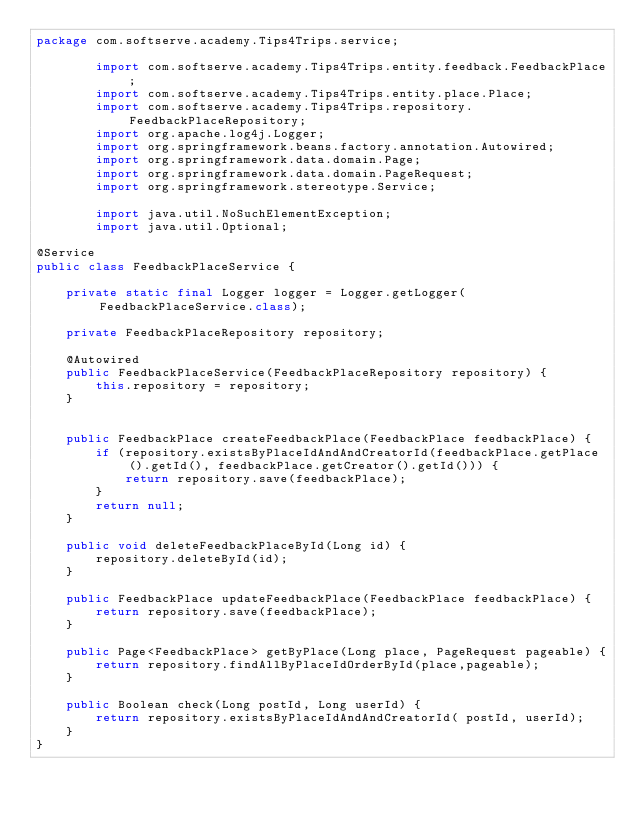Convert code to text. <code><loc_0><loc_0><loc_500><loc_500><_Java_>package com.softserve.academy.Tips4Trips.service;

        import com.softserve.academy.Tips4Trips.entity.feedback.FeedbackPlace;
        import com.softserve.academy.Tips4Trips.entity.place.Place;
        import com.softserve.academy.Tips4Trips.repository.FeedbackPlaceRepository;
        import org.apache.log4j.Logger;
        import org.springframework.beans.factory.annotation.Autowired;
        import org.springframework.data.domain.Page;
        import org.springframework.data.domain.PageRequest;
        import org.springframework.stereotype.Service;

        import java.util.NoSuchElementException;
        import java.util.Optional;

@Service
public class FeedbackPlaceService {

    private static final Logger logger = Logger.getLogger(FeedbackPlaceService.class);

    private FeedbackPlaceRepository repository;

    @Autowired
    public FeedbackPlaceService(FeedbackPlaceRepository repository) {
        this.repository = repository;
    }


    public FeedbackPlace createFeedbackPlace(FeedbackPlace feedbackPlace) {
        if (repository.existsByPlaceIdAndAndCreatorId(feedbackPlace.getPlace().getId(), feedbackPlace.getCreator().getId())) {
            return repository.save(feedbackPlace);
        }
        return null;
    }

    public void deleteFeedbackPlaceById(Long id) {
        repository.deleteById(id);
    }

    public FeedbackPlace updateFeedbackPlace(FeedbackPlace feedbackPlace) {
        return repository.save(feedbackPlace);
    }

    public Page<FeedbackPlace> getByPlace(Long place, PageRequest pageable) {
        return repository.findAllByPlaceIdOrderById(place,pageable);
    }

    public Boolean check(Long postId, Long userId) {
        return repository.existsByPlaceIdAndAndCreatorId( postId, userId);
    }
}
</code> 